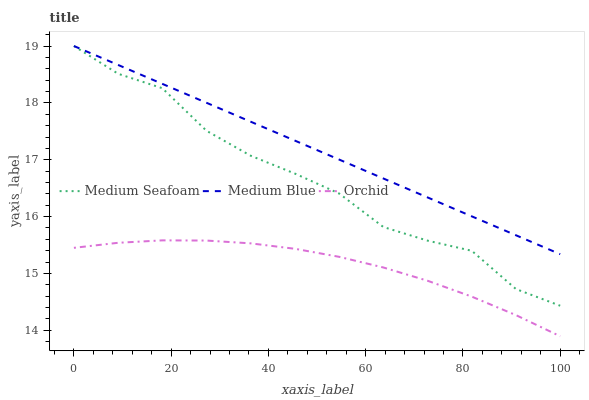Does Orchid have the minimum area under the curve?
Answer yes or no. Yes. Does Medium Blue have the maximum area under the curve?
Answer yes or no. Yes. Does Medium Seafoam have the minimum area under the curve?
Answer yes or no. No. Does Medium Seafoam have the maximum area under the curve?
Answer yes or no. No. Is Medium Blue the smoothest?
Answer yes or no. Yes. Is Medium Seafoam the roughest?
Answer yes or no. Yes. Is Orchid the smoothest?
Answer yes or no. No. Is Orchid the roughest?
Answer yes or no. No. Does Medium Seafoam have the lowest value?
Answer yes or no. No. Does Medium Seafoam have the highest value?
Answer yes or no. Yes. Does Orchid have the highest value?
Answer yes or no. No. Is Orchid less than Medium Seafoam?
Answer yes or no. Yes. Is Medium Blue greater than Orchid?
Answer yes or no. Yes. Does Medium Seafoam intersect Medium Blue?
Answer yes or no. Yes. Is Medium Seafoam less than Medium Blue?
Answer yes or no. No. Is Medium Seafoam greater than Medium Blue?
Answer yes or no. No. Does Orchid intersect Medium Seafoam?
Answer yes or no. No. 